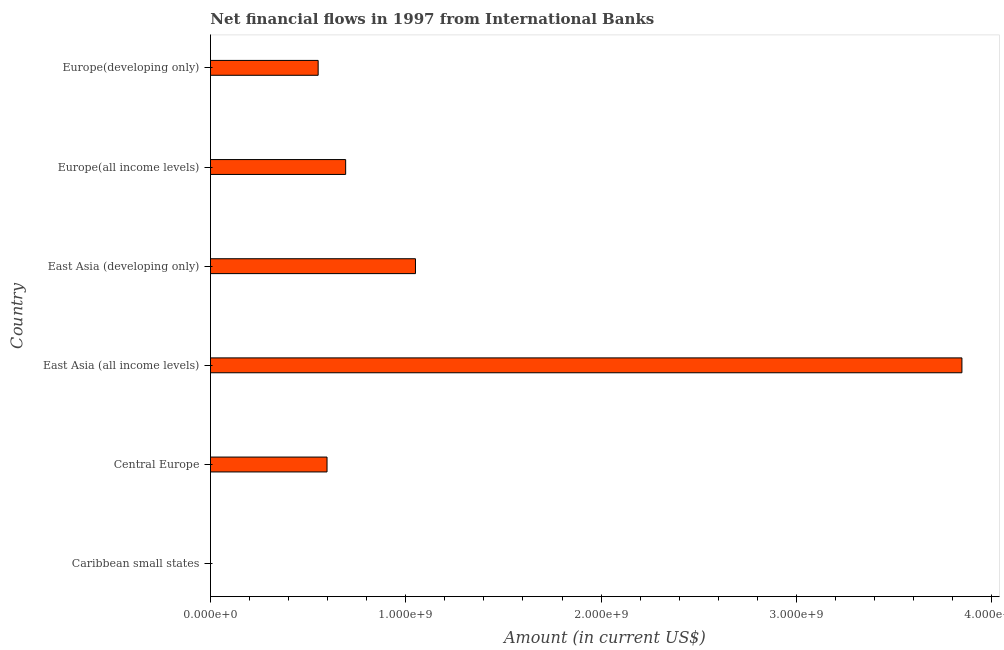Does the graph contain grids?
Offer a terse response. No. What is the title of the graph?
Give a very brief answer. Net financial flows in 1997 from International Banks. What is the label or title of the X-axis?
Your answer should be very brief. Amount (in current US$). What is the label or title of the Y-axis?
Keep it short and to the point. Country. What is the net financial flows from ibrd in East Asia (developing only)?
Provide a succinct answer. 1.05e+09. Across all countries, what is the maximum net financial flows from ibrd?
Your response must be concise. 3.85e+09. In which country was the net financial flows from ibrd maximum?
Offer a very short reply. East Asia (all income levels). What is the sum of the net financial flows from ibrd?
Offer a very short reply. 6.74e+09. What is the difference between the net financial flows from ibrd in Central Europe and East Asia (all income levels)?
Your response must be concise. -3.25e+09. What is the average net financial flows from ibrd per country?
Your answer should be very brief. 1.12e+09. What is the median net financial flows from ibrd?
Make the answer very short. 6.44e+08. In how many countries, is the net financial flows from ibrd greater than 1000000000 US$?
Offer a very short reply. 2. What is the ratio of the net financial flows from ibrd in Central Europe to that in Europe(all income levels)?
Your answer should be compact. 0.86. What is the difference between the highest and the second highest net financial flows from ibrd?
Ensure brevity in your answer.  2.80e+09. What is the difference between the highest and the lowest net financial flows from ibrd?
Provide a short and direct response. 3.85e+09. In how many countries, is the net financial flows from ibrd greater than the average net financial flows from ibrd taken over all countries?
Ensure brevity in your answer.  1. How many countries are there in the graph?
Ensure brevity in your answer.  6. What is the difference between two consecutive major ticks on the X-axis?
Keep it short and to the point. 1.00e+09. What is the Amount (in current US$) in Caribbean small states?
Ensure brevity in your answer.  0. What is the Amount (in current US$) of Central Europe?
Provide a short and direct response. 5.97e+08. What is the Amount (in current US$) in East Asia (all income levels)?
Your answer should be compact. 3.85e+09. What is the Amount (in current US$) in East Asia (developing only)?
Offer a terse response. 1.05e+09. What is the Amount (in current US$) of Europe(all income levels)?
Offer a terse response. 6.92e+08. What is the Amount (in current US$) of Europe(developing only)?
Offer a very short reply. 5.51e+08. What is the difference between the Amount (in current US$) in Central Europe and East Asia (all income levels)?
Provide a succinct answer. -3.25e+09. What is the difference between the Amount (in current US$) in Central Europe and East Asia (developing only)?
Provide a succinct answer. -4.53e+08. What is the difference between the Amount (in current US$) in Central Europe and Europe(all income levels)?
Provide a short and direct response. -9.53e+07. What is the difference between the Amount (in current US$) in Central Europe and Europe(developing only)?
Offer a terse response. 4.55e+07. What is the difference between the Amount (in current US$) in East Asia (all income levels) and East Asia (developing only)?
Provide a succinct answer. 2.80e+09. What is the difference between the Amount (in current US$) in East Asia (all income levels) and Europe(all income levels)?
Your answer should be very brief. 3.16e+09. What is the difference between the Amount (in current US$) in East Asia (all income levels) and Europe(developing only)?
Give a very brief answer. 3.30e+09. What is the difference between the Amount (in current US$) in East Asia (developing only) and Europe(all income levels)?
Provide a short and direct response. 3.57e+08. What is the difference between the Amount (in current US$) in East Asia (developing only) and Europe(developing only)?
Ensure brevity in your answer.  4.98e+08. What is the difference between the Amount (in current US$) in Europe(all income levels) and Europe(developing only)?
Keep it short and to the point. 1.41e+08. What is the ratio of the Amount (in current US$) in Central Europe to that in East Asia (all income levels)?
Ensure brevity in your answer.  0.15. What is the ratio of the Amount (in current US$) in Central Europe to that in East Asia (developing only)?
Make the answer very short. 0.57. What is the ratio of the Amount (in current US$) in Central Europe to that in Europe(all income levels)?
Make the answer very short. 0.86. What is the ratio of the Amount (in current US$) in Central Europe to that in Europe(developing only)?
Offer a very short reply. 1.08. What is the ratio of the Amount (in current US$) in East Asia (all income levels) to that in East Asia (developing only)?
Keep it short and to the point. 3.67. What is the ratio of the Amount (in current US$) in East Asia (all income levels) to that in Europe(all income levels)?
Offer a terse response. 5.56. What is the ratio of the Amount (in current US$) in East Asia (all income levels) to that in Europe(developing only)?
Your answer should be very brief. 6.98. What is the ratio of the Amount (in current US$) in East Asia (developing only) to that in Europe(all income levels)?
Provide a short and direct response. 1.52. What is the ratio of the Amount (in current US$) in East Asia (developing only) to that in Europe(developing only)?
Give a very brief answer. 1.9. What is the ratio of the Amount (in current US$) in Europe(all income levels) to that in Europe(developing only)?
Ensure brevity in your answer.  1.25. 